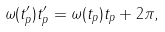Convert formula to latex. <formula><loc_0><loc_0><loc_500><loc_500>\omega ( t ^ { \prime } _ { p } ) t ^ { \prime } _ { p } = \omega ( t _ { p } ) t _ { p } + 2 \pi ,</formula> 